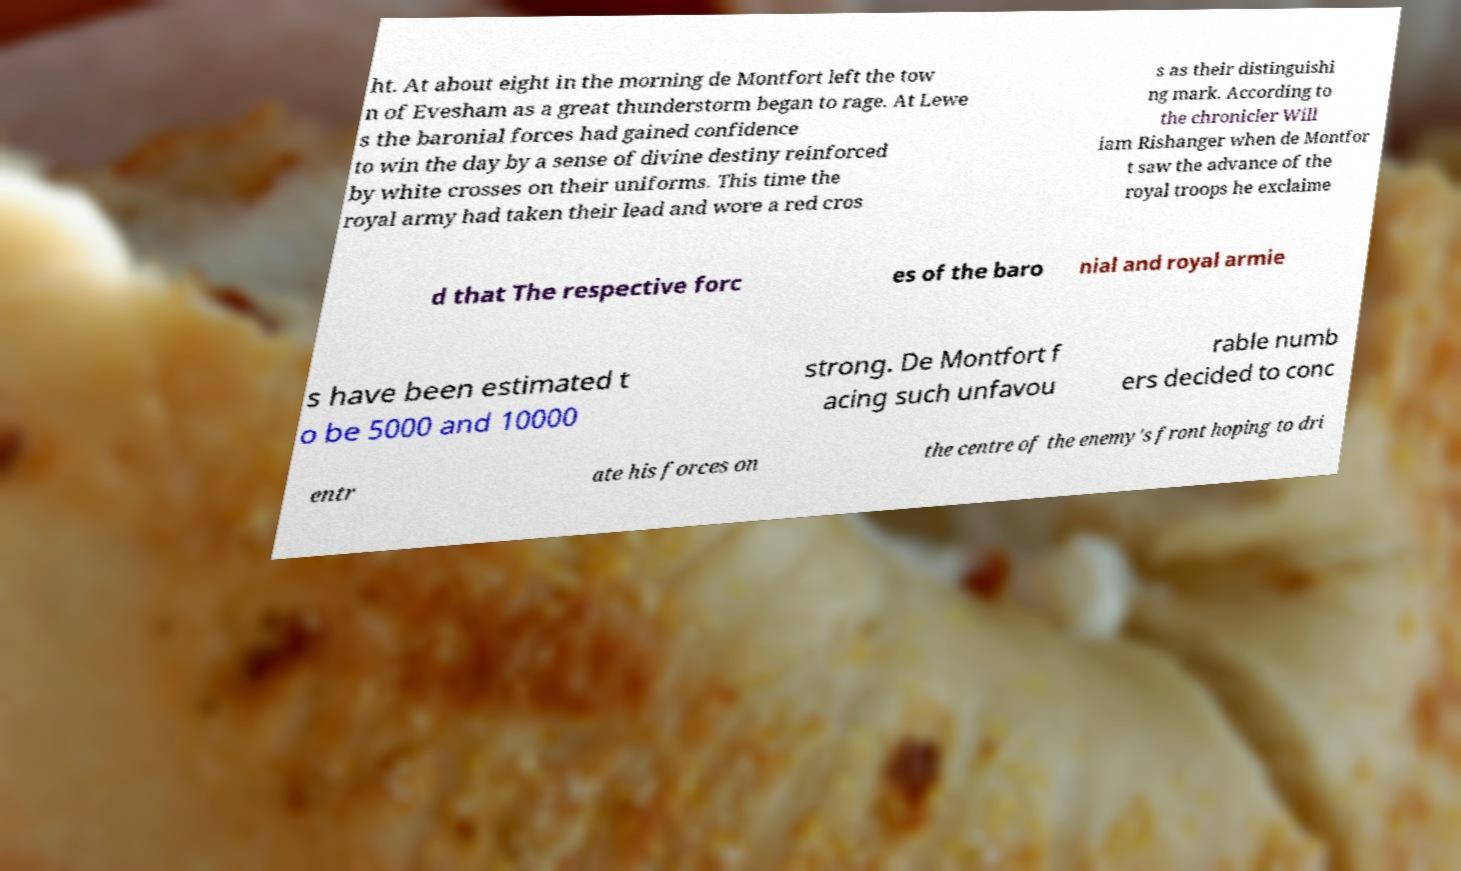For documentation purposes, I need the text within this image transcribed. Could you provide that? ht. At about eight in the morning de Montfort left the tow n of Evesham as a great thunderstorm began to rage. At Lewe s the baronial forces had gained confidence to win the day by a sense of divine destiny reinforced by white crosses on their uniforms. This time the royal army had taken their lead and wore a red cros s as their distinguishi ng mark. According to the chronicler Will iam Rishanger when de Montfor t saw the advance of the royal troops he exclaime d that The respective forc es of the baro nial and royal armie s have been estimated t o be 5000 and 10000 strong. De Montfort f acing such unfavou rable numb ers decided to conc entr ate his forces on the centre of the enemy's front hoping to dri 